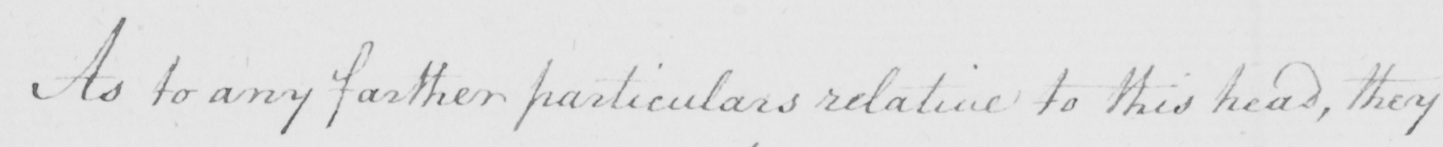Can you read and transcribe this handwriting? As to any farther particulars relative to this head , they 